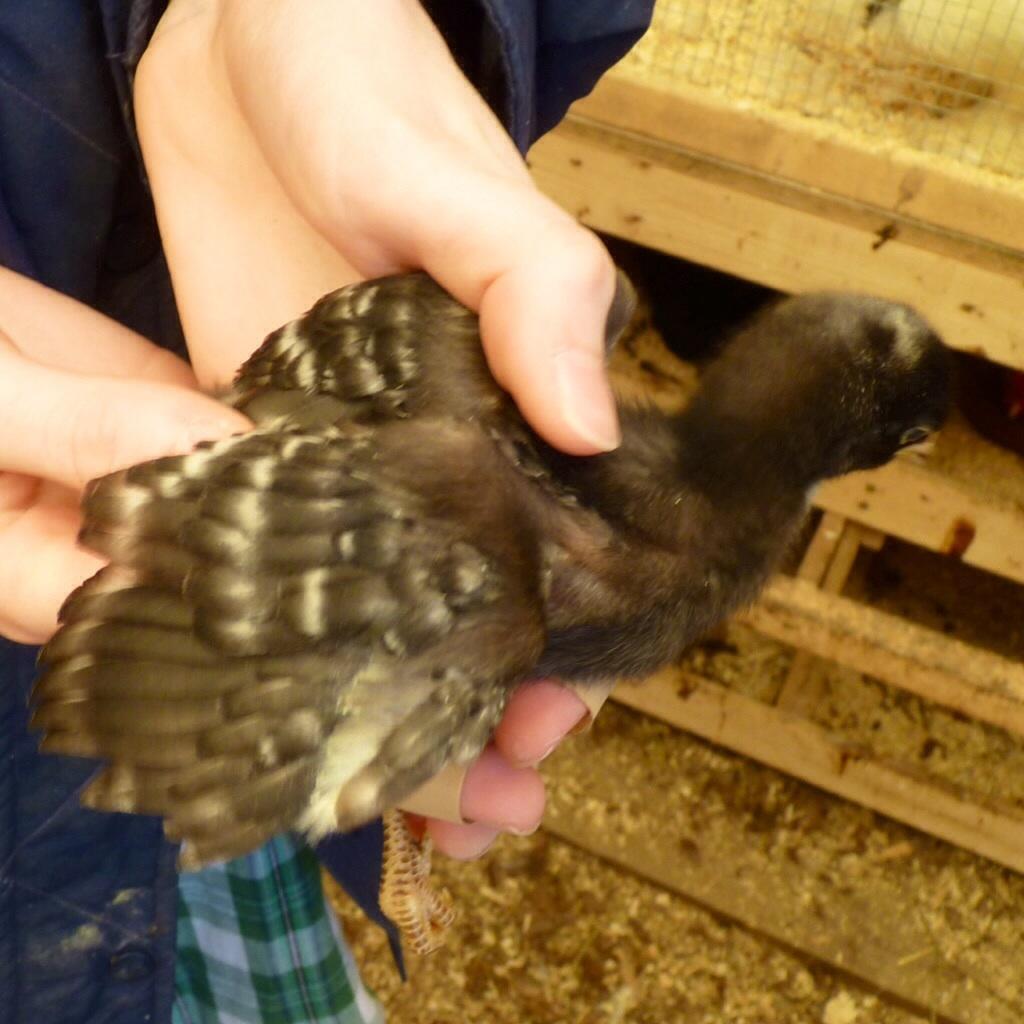In one or two sentences, can you explain what this image depicts? There is a bird in a person hands on the left and we can see a wooden object and welded mesh wire and dust on the ground. 